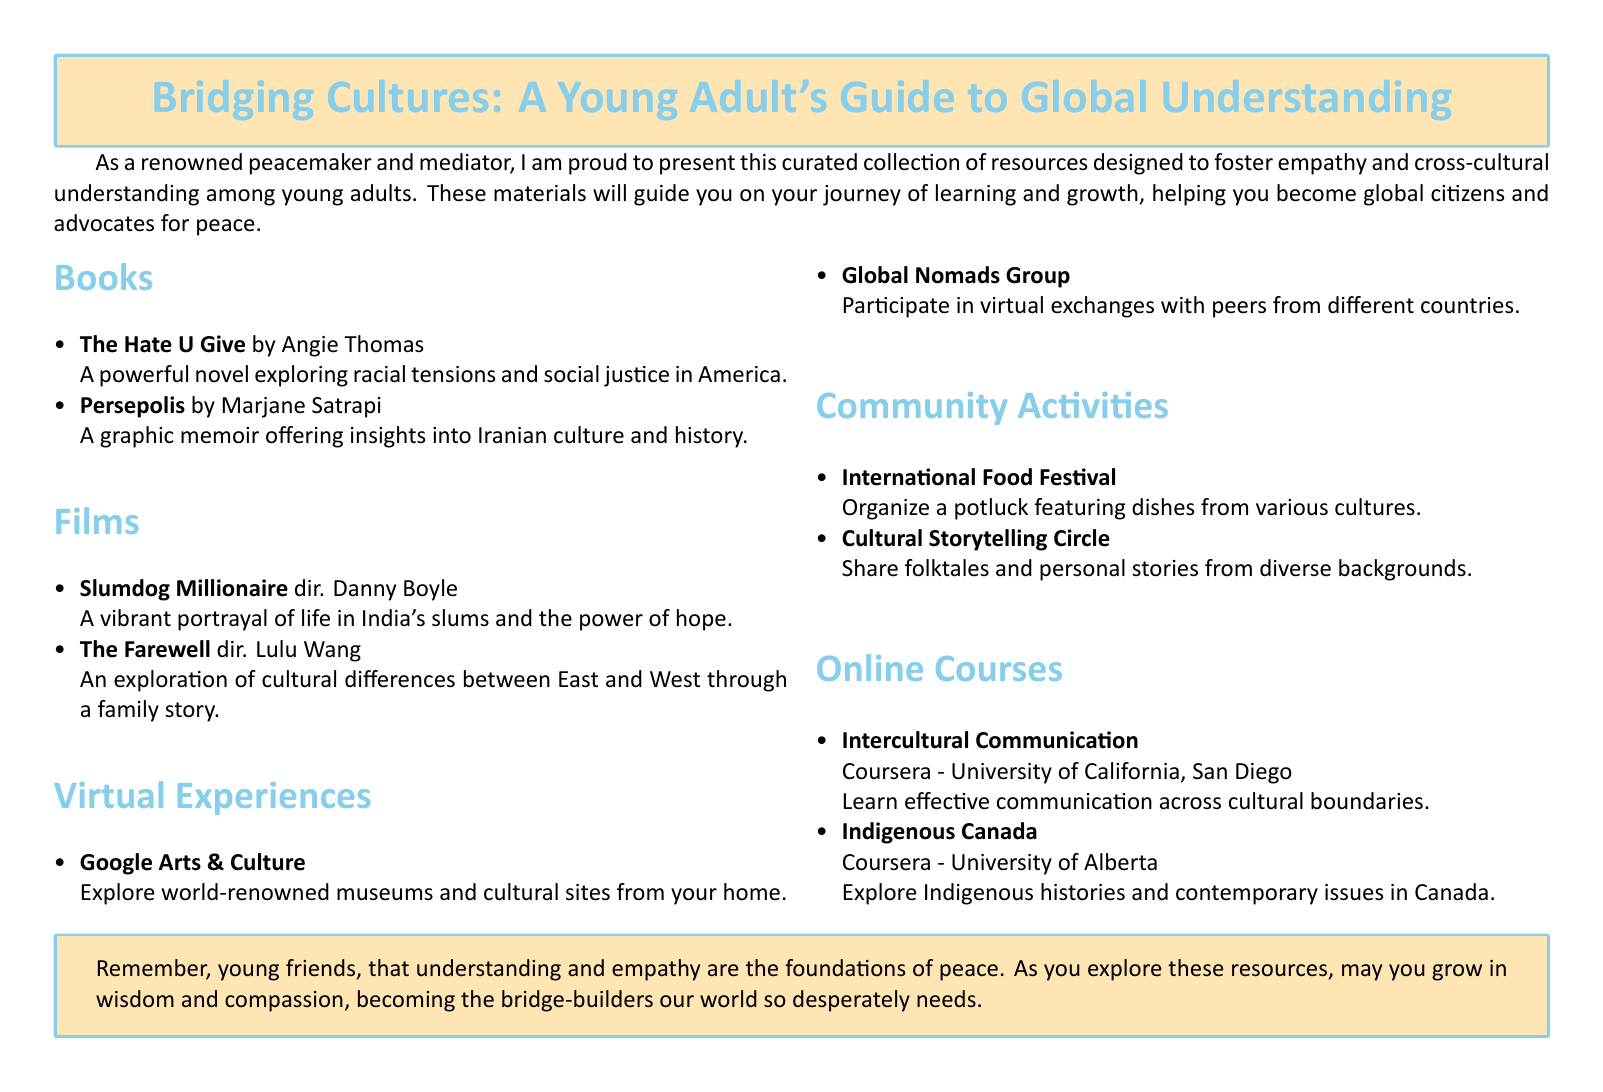What is the title of the catalog? The title of the catalog is presented at the top of the document.
Answer: Bridging Cultures: A Young Adult's Guide to Global Understanding Who is the author of "Persepolis"? The author's name is mentioned alongside the book title in the document.
Answer: Marjane Satrapi Which film is directed by Danny Boyle? This film's title is listed in the films section with its director's name.
Answer: Slumdog Millionaire What online platform offers the course "Intercultural Communication"? The document specifies the platform that hosts this course.
Answer: Coursera How many community activities are listed in the document? The number of items in the community activities section indicates this count.
Answer: Two What is the main goal of the curated resources? The introductory text outlines the purpose of the resources presented.
Answer: Foster empathy and cross-cultural understanding What activity involves sharing folktales? The specific community activity described in the document relates to storytelling.
Answer: Cultural Storytelling Circle What do the virtual exchanges with Global Nomads Group facilitate? The description in the virtual experiences section explains this aspect.
Answer: Participation with peers from different countries What type of resource is "The Hate U Give"? The document categorizes this resource under books based on its listing.
Answer: Book 